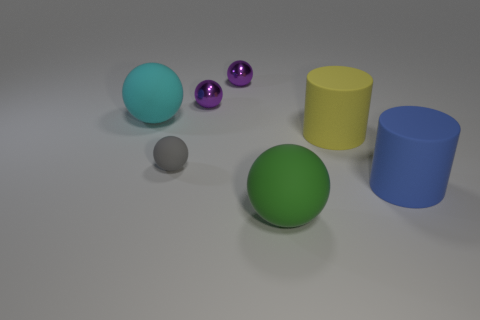Is the number of tiny balls behind the yellow matte cylinder less than the number of rubber things that are behind the large blue rubber thing?
Provide a short and direct response. Yes. Are the cylinder behind the blue cylinder and the large sphere that is to the left of the large green sphere made of the same material?
Your response must be concise. Yes. The big matte object that is in front of the small matte ball and behind the green rubber thing has what shape?
Your response must be concise. Cylinder. There is a big sphere in front of the large cyan rubber sphere left of the yellow rubber thing; what is its material?
Your answer should be very brief. Rubber. Is the number of big blue cylinders greater than the number of tiny purple rubber balls?
Ensure brevity in your answer.  Yes. What material is the cyan sphere that is the same size as the green ball?
Offer a very short reply. Rubber. Does the big cyan thing have the same material as the small gray thing?
Provide a short and direct response. Yes. How many purple spheres are the same material as the large blue cylinder?
Keep it short and to the point. 0. How many objects are balls behind the small gray rubber thing or green matte spheres right of the gray rubber object?
Make the answer very short. 4. Is the number of big yellow objects that are in front of the large yellow thing greater than the number of purple spheres behind the gray object?
Offer a very short reply. No. 